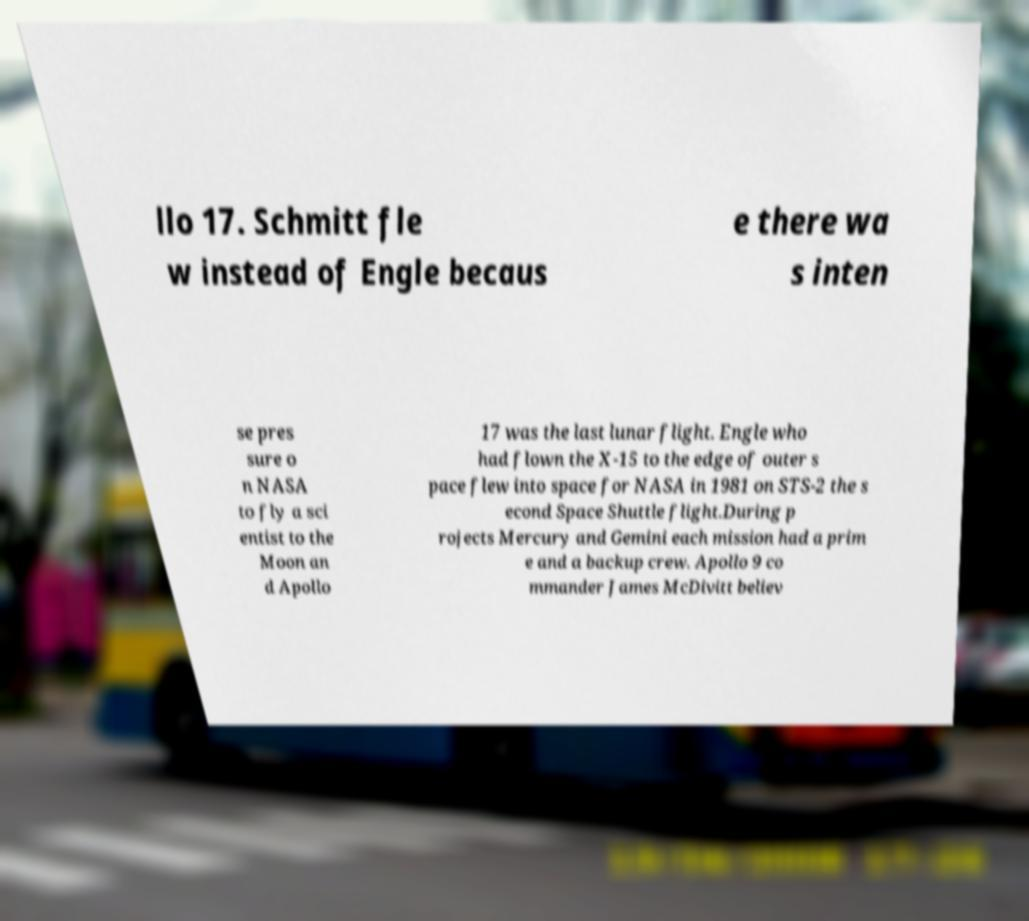Please read and relay the text visible in this image. What does it say? llo 17. Schmitt fle w instead of Engle becaus e there wa s inten se pres sure o n NASA to fly a sci entist to the Moon an d Apollo 17 was the last lunar flight. Engle who had flown the X-15 to the edge of outer s pace flew into space for NASA in 1981 on STS-2 the s econd Space Shuttle flight.During p rojects Mercury and Gemini each mission had a prim e and a backup crew. Apollo 9 co mmander James McDivitt believ 